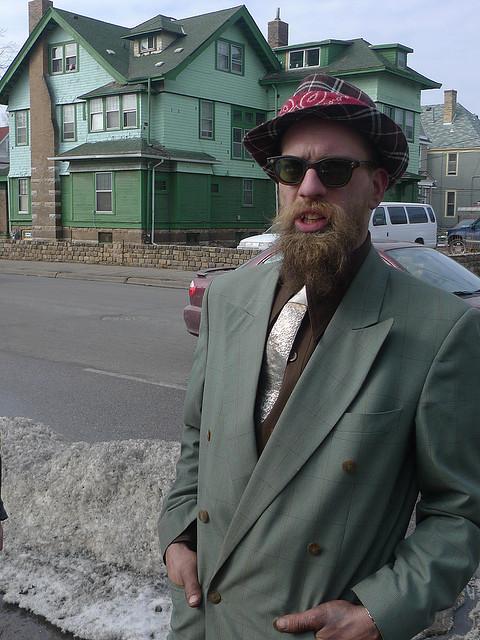Is this an old picture?
Answer briefly. No. Is the man dressed in costume?
Answer briefly. No. Is his hat solid or patterned?
Be succinct. Patterned. What is on the people's hats?
Keep it brief. Bandana. What color is the house?
Keep it brief. Green. What country was this taken in?
Short answer required. Ireland. What color is the building in the background?
Be succinct. Green. What doe the man with a green jacket have on his head?
Quick response, please. Hat. What is the color pattern on the right hat called?
Short answer required. Plaid. Is this person wearing a wig?
Give a very brief answer. No. Is this probably a bright day for this time of year?
Give a very brief answer. Yes. What is on the man's hat?
Write a very short answer. Bandana. What do you think this man is thinking?
Concise answer only. I'm angry. What material is the man's top made of?
Concise answer only. Cotton. How many men are there?
Concise answer only. 1. How many people are seen?
Concise answer only. 1. What is the hat called this person is wearing?
Short answer required. Fedora. Is the man talking on a phone?
Concise answer only. No. Is that tie in a Windsor knot?
Be succinct. No. Is the man wearing a bow tie?
Be succinct. No. What might the man's hand gesture represent or communicate?
Concise answer only. Cold. Is the man cutting a fish to eat?
Quick response, please. No. 